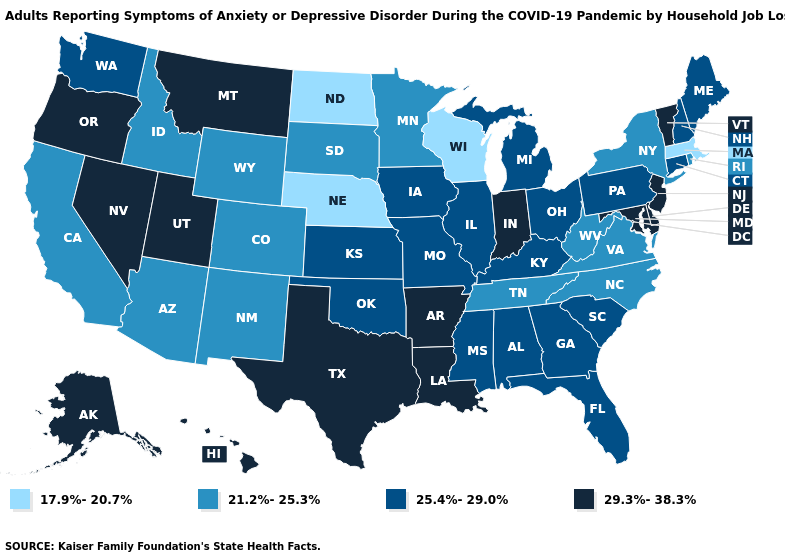Which states have the lowest value in the West?
Write a very short answer. Arizona, California, Colorado, Idaho, New Mexico, Wyoming. Name the states that have a value in the range 25.4%-29.0%?
Write a very short answer. Alabama, Connecticut, Florida, Georgia, Illinois, Iowa, Kansas, Kentucky, Maine, Michigan, Mississippi, Missouri, New Hampshire, Ohio, Oklahoma, Pennsylvania, South Carolina, Washington. Name the states that have a value in the range 17.9%-20.7%?
Keep it brief. Massachusetts, Nebraska, North Dakota, Wisconsin. What is the value of Vermont?
Short answer required. 29.3%-38.3%. Name the states that have a value in the range 29.3%-38.3%?
Give a very brief answer. Alaska, Arkansas, Delaware, Hawaii, Indiana, Louisiana, Maryland, Montana, Nevada, New Jersey, Oregon, Texas, Utah, Vermont. What is the value of Texas?
Quick response, please. 29.3%-38.3%. What is the highest value in the MidWest ?
Short answer required. 29.3%-38.3%. What is the value of Texas?
Be succinct. 29.3%-38.3%. Which states have the highest value in the USA?
Keep it brief. Alaska, Arkansas, Delaware, Hawaii, Indiana, Louisiana, Maryland, Montana, Nevada, New Jersey, Oregon, Texas, Utah, Vermont. What is the highest value in the South ?
Quick response, please. 29.3%-38.3%. Name the states that have a value in the range 29.3%-38.3%?
Give a very brief answer. Alaska, Arkansas, Delaware, Hawaii, Indiana, Louisiana, Maryland, Montana, Nevada, New Jersey, Oregon, Texas, Utah, Vermont. Which states have the lowest value in the West?
Write a very short answer. Arizona, California, Colorado, Idaho, New Mexico, Wyoming. Name the states that have a value in the range 29.3%-38.3%?
Quick response, please. Alaska, Arkansas, Delaware, Hawaii, Indiana, Louisiana, Maryland, Montana, Nevada, New Jersey, Oregon, Texas, Utah, Vermont. Which states have the highest value in the USA?
Short answer required. Alaska, Arkansas, Delaware, Hawaii, Indiana, Louisiana, Maryland, Montana, Nevada, New Jersey, Oregon, Texas, Utah, Vermont. How many symbols are there in the legend?
Give a very brief answer. 4. 